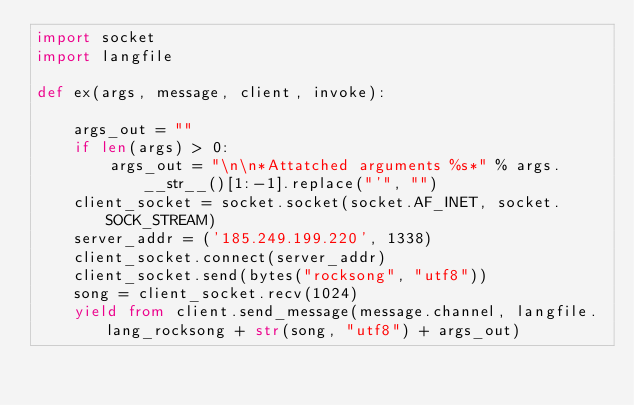Convert code to text. <code><loc_0><loc_0><loc_500><loc_500><_Python_>import socket
import langfile

def ex(args, message, client, invoke):

    args_out = ""
    if len(args) > 0:
        args_out = "\n\n*Attatched arguments %s*" % args.__str__()[1:-1].replace("'", "")
    client_socket = socket.socket(socket.AF_INET, socket.SOCK_STREAM)
    server_addr = ('185.249.199.220', 1338)
    client_socket.connect(server_addr)
    client_socket.send(bytes("rocksong", "utf8"))
    song = client_socket.recv(1024)
    yield from client.send_message(message.channel, langfile.lang_rocksong + str(song, "utf8") + args_out)
</code> 